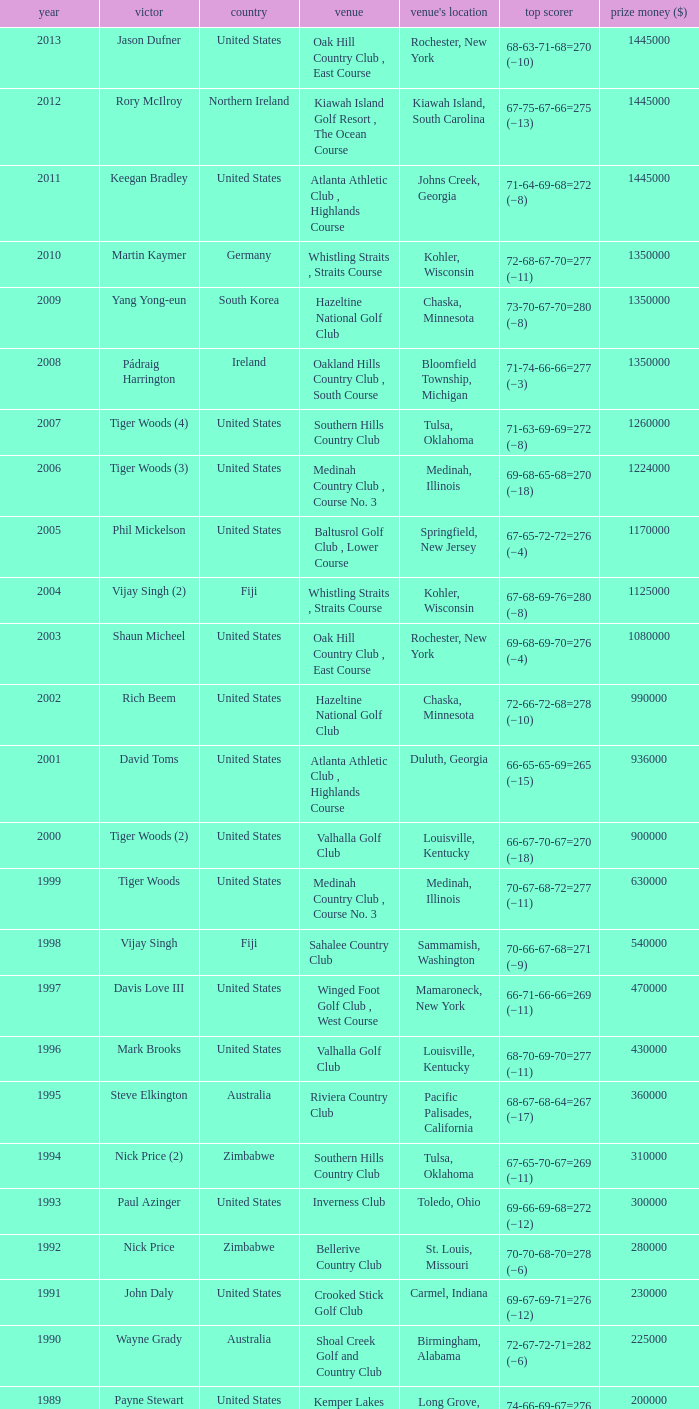Where is the Bellerive Country Club venue located? St. Louis, Missouri. Help me parse the entirety of this table. {'header': ['year', 'victor', 'country', 'venue', "venue's location", 'top scorer', 'prize money ($)'], 'rows': [['2013', 'Jason Dufner', 'United States', 'Oak Hill Country Club , East Course', 'Rochester, New York', '68-63-71-68=270 (−10)', '1445000'], ['2012', 'Rory McIlroy', 'Northern Ireland', 'Kiawah Island Golf Resort , The Ocean Course', 'Kiawah Island, South Carolina', '67-75-67-66=275 (−13)', '1445000'], ['2011', 'Keegan Bradley', 'United States', 'Atlanta Athletic Club , Highlands Course', 'Johns Creek, Georgia', '71-64-69-68=272 (−8)', '1445000'], ['2010', 'Martin Kaymer', 'Germany', 'Whistling Straits , Straits Course', 'Kohler, Wisconsin', '72-68-67-70=277 (−11)', '1350000'], ['2009', 'Yang Yong-eun', 'South Korea', 'Hazeltine National Golf Club', 'Chaska, Minnesota', '73-70-67-70=280 (−8)', '1350000'], ['2008', 'Pádraig Harrington', 'Ireland', 'Oakland Hills Country Club , South Course', 'Bloomfield Township, Michigan', '71-74-66-66=277 (−3)', '1350000'], ['2007', 'Tiger Woods (4)', 'United States', 'Southern Hills Country Club', 'Tulsa, Oklahoma', '71-63-69-69=272 (−8)', '1260000'], ['2006', 'Tiger Woods (3)', 'United States', 'Medinah Country Club , Course No. 3', 'Medinah, Illinois', '69-68-65-68=270 (−18)', '1224000'], ['2005', 'Phil Mickelson', 'United States', 'Baltusrol Golf Club , Lower Course', 'Springfield, New Jersey', '67-65-72-72=276 (−4)', '1170000'], ['2004', 'Vijay Singh (2)', 'Fiji', 'Whistling Straits , Straits Course', 'Kohler, Wisconsin', '67-68-69-76=280 (−8)', '1125000'], ['2003', 'Shaun Micheel', 'United States', 'Oak Hill Country Club , East Course', 'Rochester, New York', '69-68-69-70=276 (−4)', '1080000'], ['2002', 'Rich Beem', 'United States', 'Hazeltine National Golf Club', 'Chaska, Minnesota', '72-66-72-68=278 (−10)', '990000'], ['2001', 'David Toms', 'United States', 'Atlanta Athletic Club , Highlands Course', 'Duluth, Georgia', '66-65-65-69=265 (−15)', '936000'], ['2000', 'Tiger Woods (2)', 'United States', 'Valhalla Golf Club', 'Louisville, Kentucky', '66-67-70-67=270 (−18)', '900000'], ['1999', 'Tiger Woods', 'United States', 'Medinah Country Club , Course No. 3', 'Medinah, Illinois', '70-67-68-72=277 (−11)', '630000'], ['1998', 'Vijay Singh', 'Fiji', 'Sahalee Country Club', 'Sammamish, Washington', '70-66-67-68=271 (−9)', '540000'], ['1997', 'Davis Love III', 'United States', 'Winged Foot Golf Club , West Course', 'Mamaroneck, New York', '66-71-66-66=269 (−11)', '470000'], ['1996', 'Mark Brooks', 'United States', 'Valhalla Golf Club', 'Louisville, Kentucky', '68-70-69-70=277 (−11)', '430000'], ['1995', 'Steve Elkington', 'Australia', 'Riviera Country Club', 'Pacific Palisades, California', '68-67-68-64=267 (−17)', '360000'], ['1994', 'Nick Price (2)', 'Zimbabwe', 'Southern Hills Country Club', 'Tulsa, Oklahoma', '67-65-70-67=269 (−11)', '310000'], ['1993', 'Paul Azinger', 'United States', 'Inverness Club', 'Toledo, Ohio', '69-66-69-68=272 (−12)', '300000'], ['1992', 'Nick Price', 'Zimbabwe', 'Bellerive Country Club', 'St. Louis, Missouri', '70-70-68-70=278 (−6)', '280000'], ['1991', 'John Daly', 'United States', 'Crooked Stick Golf Club', 'Carmel, Indiana', '69-67-69-71=276 (−12)', '230000'], ['1990', 'Wayne Grady', 'Australia', 'Shoal Creek Golf and Country Club', 'Birmingham, Alabama', '72-67-72-71=282 (−6)', '225000'], ['1989', 'Payne Stewart', 'United States', 'Kemper Lakes Golf Club', 'Long Grove, Illinois', '74-66-69-67=276 (−12)', '200000'], ['1988', 'Jeff Sluman', 'United States', 'Oak Tree Golf Club', 'Edmond, Oklahoma', '69-70-68-65=272 (−12)', '160000'], ['1987', 'Larry Nelson (2)', 'United States', 'PGA National Resort & Spa', 'Palm Beach Gardens, Florida', '70-72-73-72=287 (−1)', '150000'], ['1986', 'Bob Tway', 'United States', 'Inverness Club', 'Toledo, Ohio', '72-70-64-70=276 (−8)', '145000'], ['1985', 'Hubert Green', 'United States', 'Cherry Hills Country Club', 'Cherry Hills Village, Colorado', '67-69-70-72=278 (−6)', '125000'], ['1984', 'Lee Trevino (2)', 'United States', 'Shoal Creek Golf and Country Club', 'Birmingham, Alabama', '69-68-67-69=273 (−15)', '125000'], ['1983', 'Hal Sutton', 'United States', 'Riviera Country Club', 'Pacific Palisades, California', '65-66-72-71=274 (−10)', '100000'], ['1982', 'Raymond Floyd (2)', 'United States', 'Southern Hills Country Club', 'Tulsa, Oklahoma', '63-69-68-72=272 (−8)', '65000'], ['1981', 'Larry Nelson', 'United States', 'Atlanta Athletic Club , Highlands Course', 'Duluth, Georgia', '70-66-66-71=273 (−7)', '60000'], ['1980', 'Jack Nicklaus (5)', 'United States', 'Oak Hill Country Club , East Course', 'Rochester, New York', '70-69-66-69=274 (−6)', '60000'], ['1979', 'David Graham', 'Australia', 'Oakland Hills Country Club , South Course', 'Bloomfield Township, Michigan', '69-68-70-65=272 (−8)', '60000'], ['1978', 'John Mahaffey', 'United States', 'Oakmont Country Club', 'Oakmont, Pennsylvania', '75-67-68-66=276 (−8)', '50000'], ['1977', 'Lanny Wadkins', 'United States', 'Pebble Beach Golf Links', 'Pebble Beach, California', '69-71-72-70=282 (−6)', '45000'], ['1976', 'Dave Stockton (2)', 'United States', 'Congressional Country Club , Blue Course', 'Bethesda, Maryland', '70-72-69-70=281 (+1)', '45000'], ['1975', 'Jack Nicklaus (4)', 'United States', 'Firestone Country Club , South Course', 'Akron, Ohio', '70-68-67-71=276 (−4)', '45000'], ['1974', 'Lee Trevino', 'United States', 'Tanglewood Park , Championship Course', 'Clemmons, North Carolina', '73-66-68-69=276 (−4)', '45000'], ['1973', 'Jack Nicklaus (3)', 'United States', 'Canterbury Golf Club', 'Beachwood, Ohio', '72-68-68-69=277 (−7)', '45000'], ['1972', 'Gary Player (2)', 'South Africa', 'Oakland Hills Country Club , South Course', 'Bloomfield Hills, Michigan', '71-71-67-72=281 (+1)', '45000'], ['1971', 'Jack Nicklaus (2)', 'United States', 'PGA National Golf Club', 'Palm Beach Gardens, Florida', '69-69-70-73=281 (−7)', '40000'], ['1970', 'Dave Stockton', 'United States', 'Southern Hills Country Club', 'Tulsa, Oklahoma', '70-70-66-73=279 (−1)', '40000'], ['1969', 'Raymond Floyd', 'United States', 'NCR Country Club , South Course', 'Dayton, Ohio', '69-66-67-74=276 (−8)', '35000'], ['1968', 'Julius Boros', 'United States', 'Pecan Valley Golf Club', 'San Antonio, Texas', '71-71-70-69=281 (+1)', '25000'], ['1967', 'Don January', 'United States', 'Columbine Country Club', 'Columbine Valley, Colorado', '71-72-70-68=281 (−7)', '25000'], ['1966', 'Al Geiberger', 'United States', 'Firestone Country Club , South Course', 'Akron, Ohio', '68-72-68-72=280 (E)', '25000'], ['1965', 'Dave Marr', 'United States', 'Laurel Valley Golf Club', 'Ligonier, Pennsylvania', '70-69-70-71=280 (−4)', '25000'], ['1964', 'Bobby Nichols', 'United States', 'Columbus Country Club', 'Columbus, Ohio', '64-71-69-67=271 (−9)', '18000'], ['1963', 'Jack Nicklaus', 'United States', 'Dallas Athletic Club , Blue Course', 'Dallas, Texas', '69-73-69-68=279 (−5)', '13000'], ['1962', 'Gary Player', 'South Africa', 'Aronimink Golf Club', 'Newtown Square, Pennsylvania', '72-67-69-70=278 (−2)', '13000'], ['1961', 'Jerry Barber', 'United States', 'Olympia Fields Country Club', 'Olympia Fields, Illinois', '69-67-71-70=277 (−3)', '11000'], ['1960', 'Jay Hebert', 'United States', 'Firestone Country Club , South Course', 'Akron, Ohio', '72-67-72-70=281 (+1)', '11000'], ['1959', 'Bob Rosburg', 'United States', 'Minneapolis Golf Club', 'Minneapolis, Minnesota', '71-72-68-66=277 (−3)', '8250']]} 